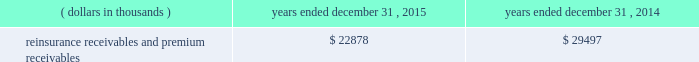Certain reclassifications and format changes have been made to prior years 2019 amounts to conform to the 2015 presentation .
Investments .
Fixed maturity and equity security investments available for sale , at market value , reflect unrealized appreciation and depreciation , as a result of temporary changes in market value during the period , in shareholders 2019 equity , net of income taxes in 201caccumulated other comprehensive income ( loss ) 201d in the consolidated balance sheets .
Fixed maturity and equity securities carried at fair value reflect fair value re- measurements as net realized capital gains and losses in the consolidated statements of operations and comprehensive income ( loss ) .
The company records changes in fair value for its fixed maturities available for sale , at market value through shareholders 2019 equity , net of taxes in accumulated other comprehensive income ( loss ) since cash flows from these investments will be primarily used to settle its reserve for losses and loss adjustment expense liabilities .
The company anticipates holding these investments for an extended period as the cash flow from interest and maturities will fund the projected payout of these liabilities .
Fixed maturities carried at fair value represent a portfolio of convertible bond securities , which have characteristics similar to equity securities and at times , designated foreign denominated fixed maturity securities , which will be used to settle loss and loss adjustment reserves in the same currency .
The company carries all of its equity securities at fair value except for mutual fund investments whose underlying investments are comprised of fixed maturity securities .
For equity securities , available for sale , at fair value , the company reflects changes in value as net realized capital gains and losses since these securities may be sold in the near term depending on financial market conditions .
Interest income on all fixed maturities and dividend income on all equity securities are included as part of net investment income in the consolidated statements of operations and comprehensive income ( loss ) .
Unrealized losses on fixed maturities , which are deemed other-than-temporary and related to the credit quality of a security , are charged to net income ( loss ) as net realized capital losses .
Short-term investments are stated at cost , which approximates market value .
Realized gains or losses on sales of investments are determined on the basis of identified cost .
For non- publicly traded securities , market prices are determined through the use of pricing models that evaluate securities relative to the u.s .
Treasury yield curve , taking into account the issue type , credit quality , and cash flow characteristics of each security .
For publicly traded securities , market value is based on quoted market prices or valuation models that use observable market inputs .
When a sector of the financial markets is inactive or illiquid , the company may use its own assumptions about future cash flows and risk-adjusted discount rates to determine fair value .
Retrospective adjustments are employed to recalculate the values of asset-backed securities .
Each acquisition lot is reviewed to recalculate the effective yield .
The recalculated effective yield is used to derive a book value as if the new yield were applied at the time of acquisition .
Outstanding principal factors from the time of acquisition to the adjustment date are used to calculate the prepayment history for all applicable securities .
Conditional prepayment rates , computed with life to date factor histories and weighted average maturities , are used to effect the calculation of projected and prepayments for pass-through security types .
Other invested assets include limited partnerships and rabbi trusts .
Limited partnerships are accounted for under the equity method of accounting , which can be recorded on a monthly or quarterly lag .
Uncollectible receivable balances .
The company provides reserves for uncollectible reinsurance recoverable and premium receivable balances based on management 2019s assessment of the collectability of the outstanding balances .
Such reserves are presented in the table below for the periods indicated. .

What is the change in the reinsurance receivables and premium receivables from 2014 to 2015 in thousands? 
Computations: (22878 - 29497)
Answer: -6619.0. 